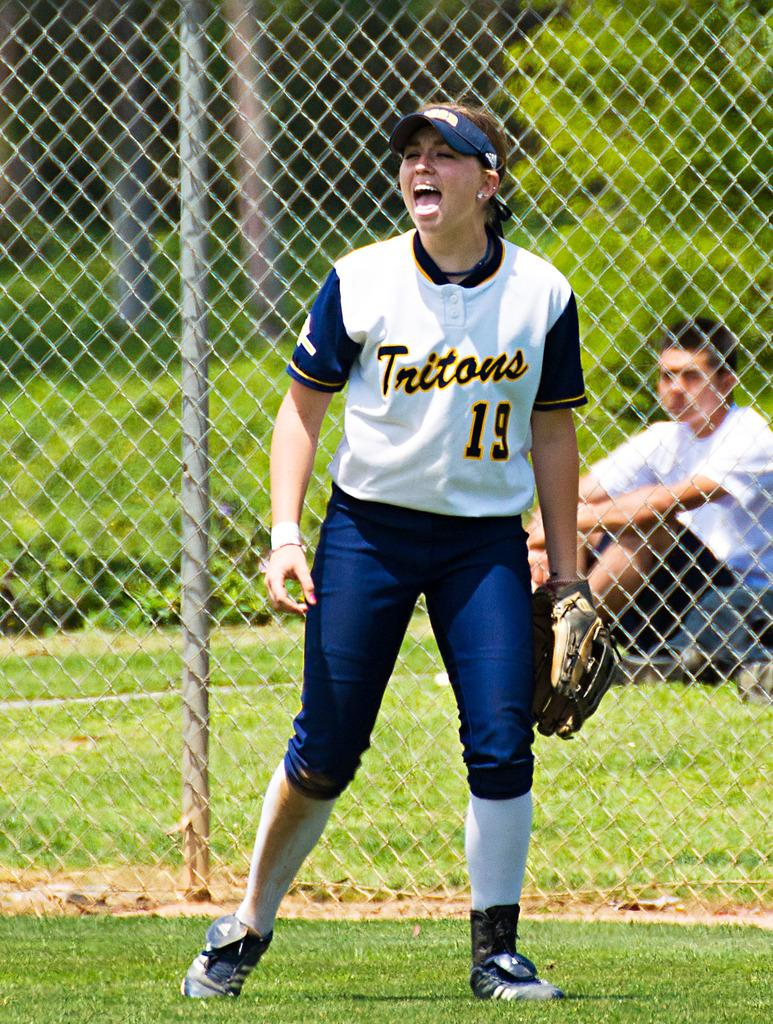<image>
Write a terse but informative summary of the picture. A female softball player for the Tritons sticks her tongue out in a teasing manner. 